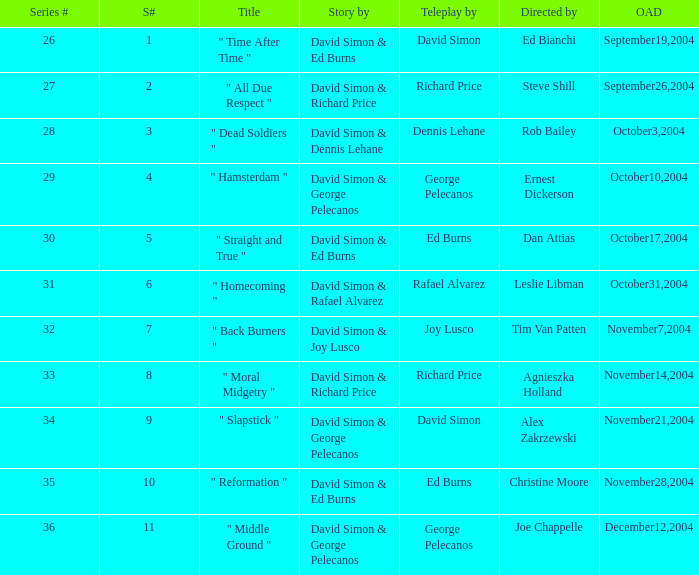What is the season # for a teleplay by Richard Price and the director is Steve Shill? 2.0. 